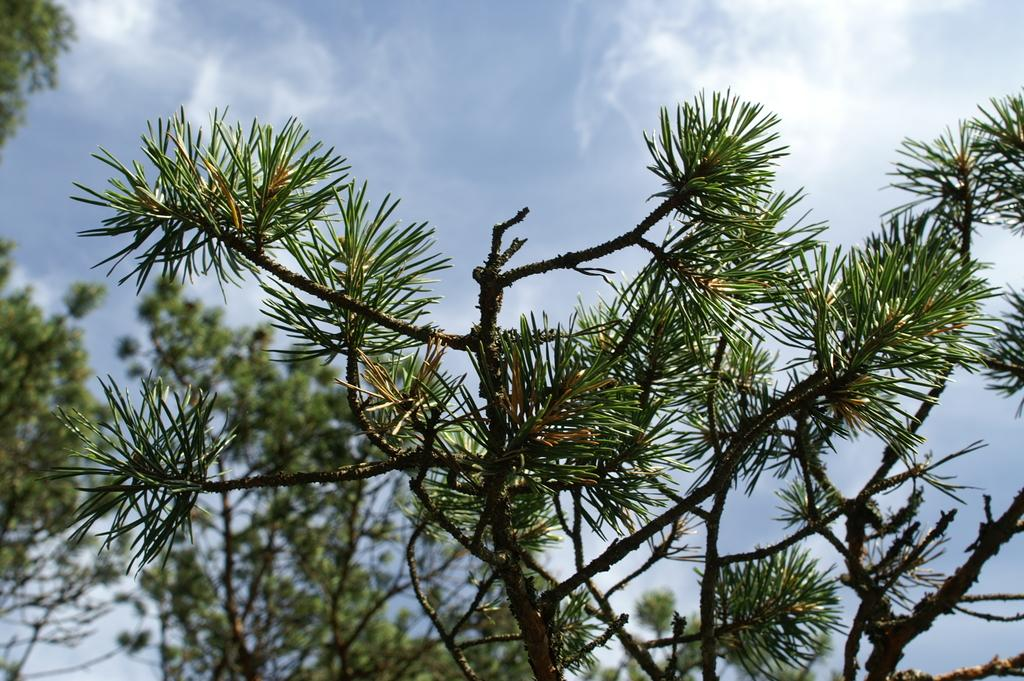What type of vegetation is present in the image? There are branches with leaves in the image. What else can be seen in the background of the image? There are trees visible in the background of the image. What part of the natural environment is visible in the background of the image? The sky is visible in the background of the image. What type of muscle can be seen flexing in the image? There is no muscle present in the image; it features branches with leaves, trees, and the sky. 